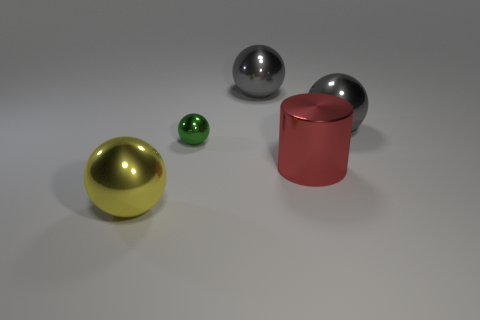Can you describe the finish of the small green object compared to the other objects? The small green object has a matte finish which scatters light diffusely, unlike the smooth and shiny metal finishes of the spherical and cylindrical objects that reflect light sharply, reaffirming their polished surfaces. 